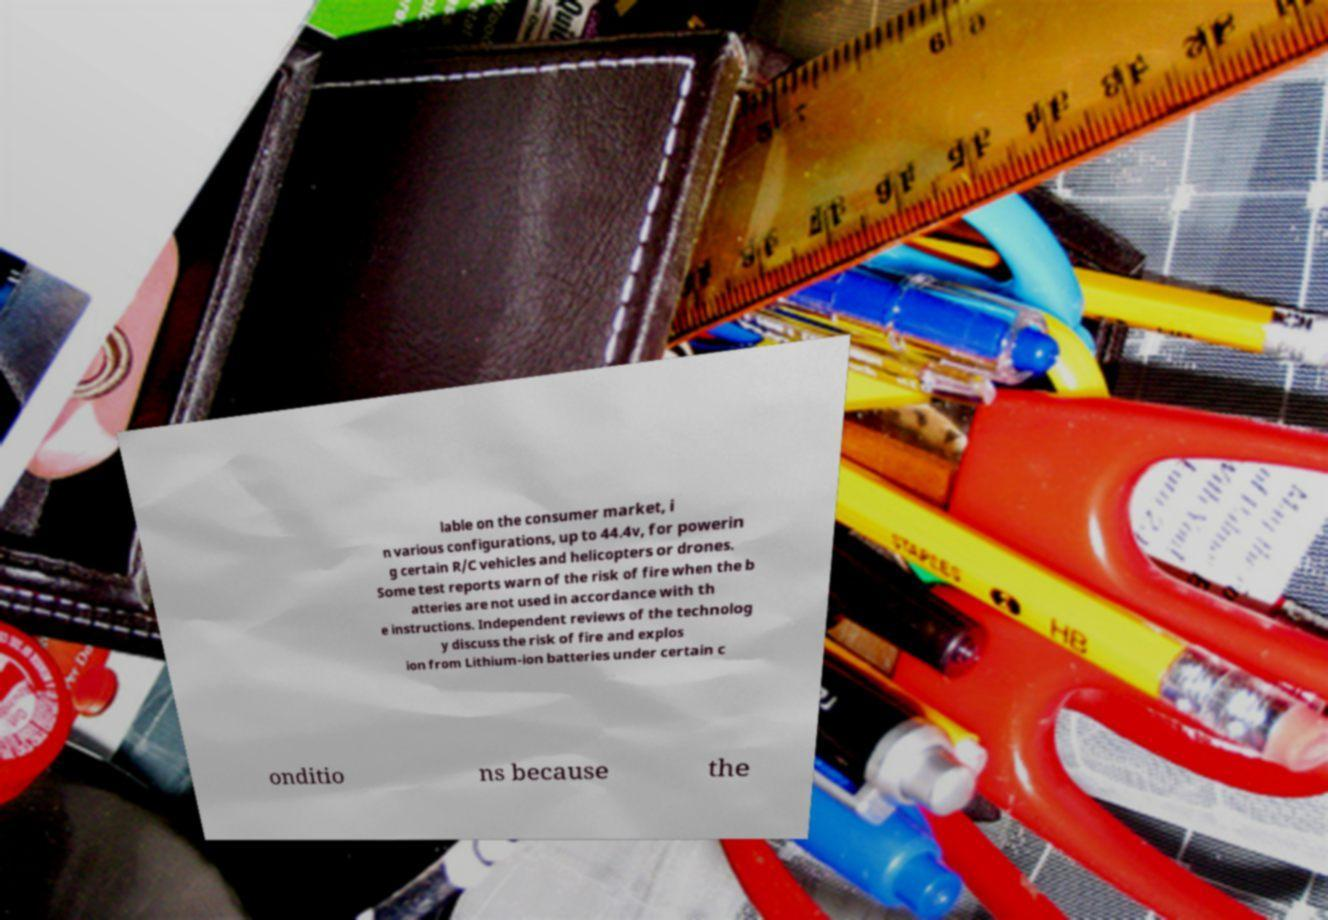Please read and relay the text visible in this image. What does it say? lable on the consumer market, i n various configurations, up to 44.4v, for powerin g certain R/C vehicles and helicopters or drones. Some test reports warn of the risk of fire when the b atteries are not used in accordance with th e instructions. Independent reviews of the technolog y discuss the risk of fire and explos ion from Lithium-ion batteries under certain c onditio ns because the 